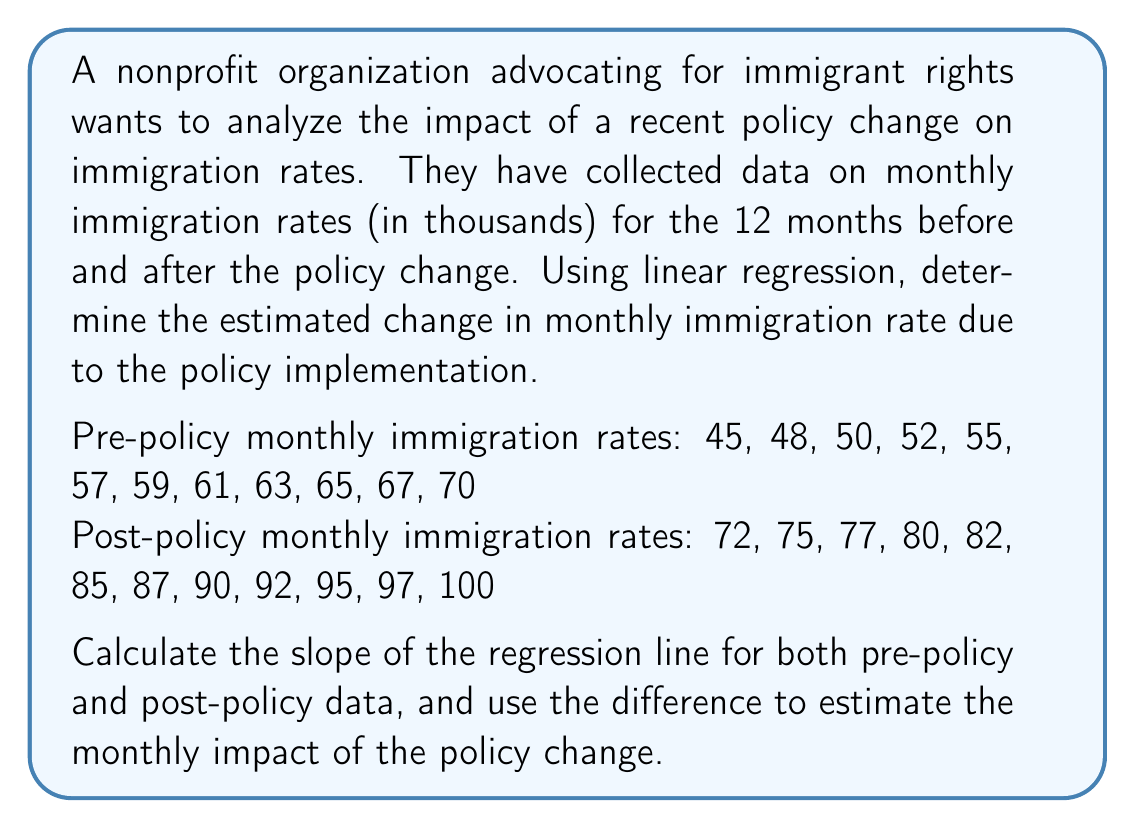What is the answer to this math problem? To solve this problem, we'll follow these steps:

1. Calculate the slope of the regression line for pre-policy data.
2. Calculate the slope of the regression line for post-policy data.
3. Find the difference between the two slopes to estimate the policy impact.

For both pre-policy and post-policy data, we'll use the formula for the slope of a regression line:

$$ m = \frac{n\sum xy - \sum x \sum y}{n\sum x^2 - (\sum x)^2} $$

Where:
$n$ is the number of data points
$x$ represents the month number (1 to 12)
$y$ represents the immigration rate

Step 1: Pre-policy slope

$n = 12$
$\sum x = 1 + 2 + ... + 12 = 78$
$\sum y = 45 + 48 + ... + 70 = 692$
$\sum xy = 1(45) + 2(48) + ... + 12(70) = 5,170$
$\sum x^2 = 1^2 + 2^2 + ... + 12^2 = 650$

$$ m_{pre} = \frac{12(5,170) - 78(692)}{12(650) - 78^2} = \frac{62,040 - 53,976}{7,800 - 6,084} = \frac{8,064}{1,716} = 2.35 $$

Step 2: Post-policy slope

$n = 12$
$\sum x = 1 + 2 + ... + 12 = 78$
$\sum y = 72 + 75 + ... + 100 = 932$
$\sum xy = 1(72) + 2(75) + ... + 12(100) = 7,038$
$\sum x^2 = 1^2 + 2^2 + ... + 12^2 = 650$

$$ m_{post} = \frac{12(7,038) - 78(932)}{12(650) - 78^2} = \frac{84,456 - 72,696}{7,800 - 6,084} = \frac{11,760}{1,716} = 2.85 $$

Step 3: Estimate policy impact

The estimated change in monthly immigration rate due to the policy implementation is the difference between the two slopes:

$$ \text{Impact} = m_{post} - m_{pre} = 2.85 - 2.35 = 0.50 $$

This means that the policy change is estimated to increase the monthly immigration rate by 0.50 thousand (or 500 people) per month.
Answer: 0.50 thousand per month 